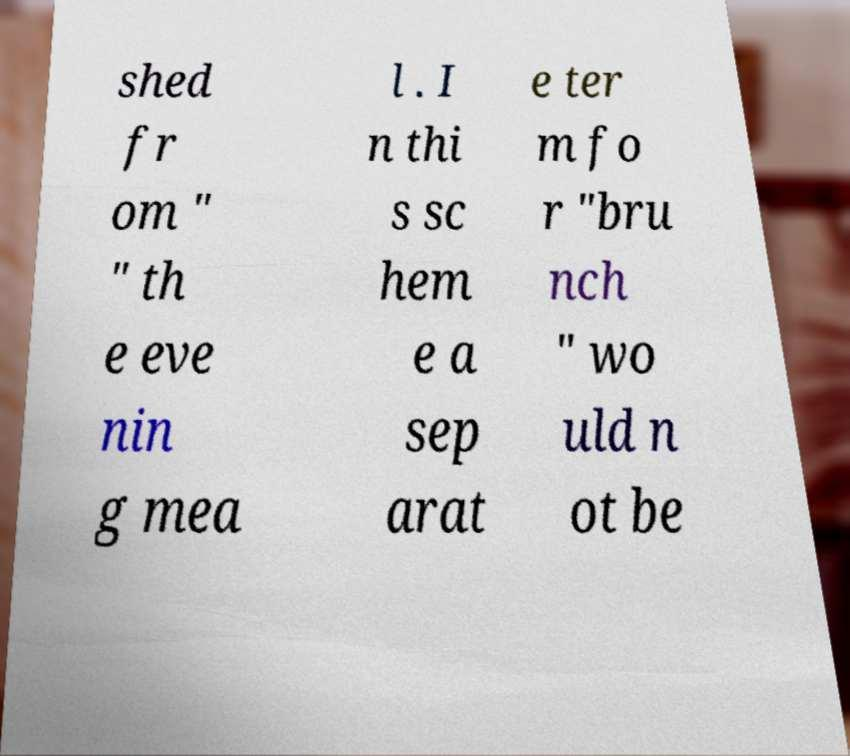There's text embedded in this image that I need extracted. Can you transcribe it verbatim? shed fr om " " th e eve nin g mea l . I n thi s sc hem e a sep arat e ter m fo r "bru nch " wo uld n ot be 